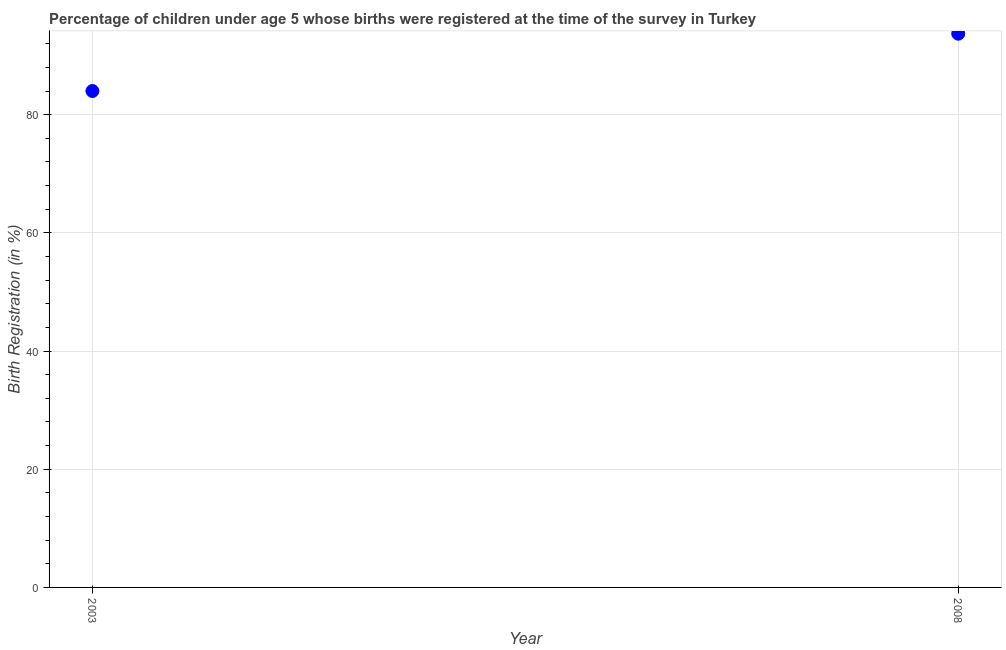What is the birth registration in 2008?
Your answer should be compact. 93.7. Across all years, what is the maximum birth registration?
Offer a terse response. 93.7. In which year was the birth registration minimum?
Your response must be concise. 2003. What is the sum of the birth registration?
Your answer should be compact. 177.7. What is the difference between the birth registration in 2003 and 2008?
Provide a short and direct response. -9.7. What is the average birth registration per year?
Ensure brevity in your answer.  88.85. What is the median birth registration?
Your response must be concise. 88.85. What is the ratio of the birth registration in 2003 to that in 2008?
Provide a short and direct response. 0.9. Is the birth registration in 2003 less than that in 2008?
Give a very brief answer. Yes. In how many years, is the birth registration greater than the average birth registration taken over all years?
Your response must be concise. 1. Does the birth registration monotonically increase over the years?
Offer a very short reply. Yes. What is the difference between two consecutive major ticks on the Y-axis?
Your response must be concise. 20. Are the values on the major ticks of Y-axis written in scientific E-notation?
Offer a terse response. No. What is the title of the graph?
Your answer should be very brief. Percentage of children under age 5 whose births were registered at the time of the survey in Turkey. What is the label or title of the Y-axis?
Ensure brevity in your answer.  Birth Registration (in %). What is the Birth Registration (in %) in 2003?
Keep it short and to the point. 84. What is the Birth Registration (in %) in 2008?
Provide a succinct answer. 93.7. What is the ratio of the Birth Registration (in %) in 2003 to that in 2008?
Make the answer very short. 0.9. 